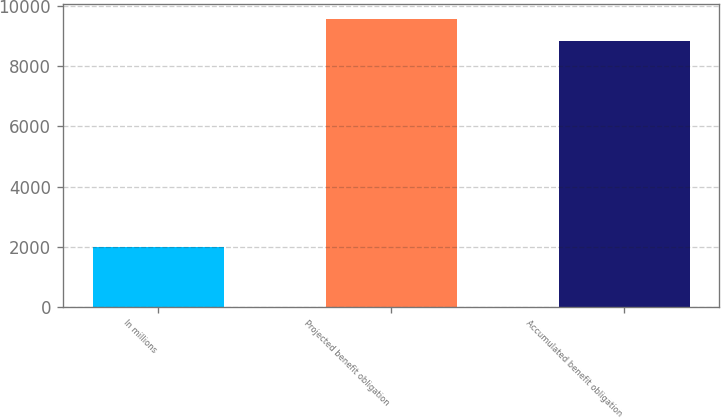Convert chart. <chart><loc_0><loc_0><loc_500><loc_500><bar_chart><fcel>In millions<fcel>Projected benefit obligation<fcel>Accumulated benefit obligation<nl><fcel>2005<fcel>9582.3<fcel>8855<nl></chart> 